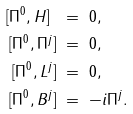Convert formula to latex. <formula><loc_0><loc_0><loc_500><loc_500>[ \Pi ^ { 0 } , H ] \ & = \ 0 , \\ [ \Pi ^ { 0 } , \Pi ^ { j } ] \ & = \ 0 , \\ [ \Pi ^ { 0 } , L ^ { j } ] \ & = \ 0 , \\ [ \Pi ^ { 0 } , B ^ { j } ] \ & = \ - i \Pi ^ { j } .</formula> 